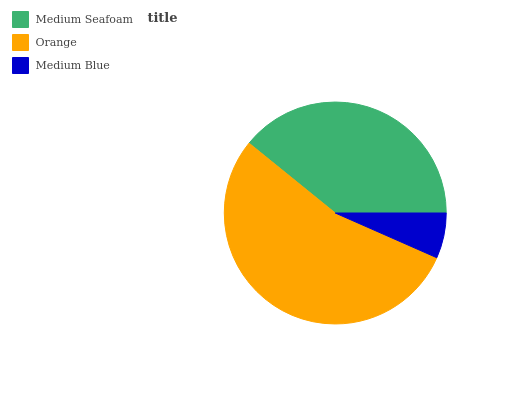Is Medium Blue the minimum?
Answer yes or no. Yes. Is Orange the maximum?
Answer yes or no. Yes. Is Orange the minimum?
Answer yes or no. No. Is Medium Blue the maximum?
Answer yes or no. No. Is Orange greater than Medium Blue?
Answer yes or no. Yes. Is Medium Blue less than Orange?
Answer yes or no. Yes. Is Medium Blue greater than Orange?
Answer yes or no. No. Is Orange less than Medium Blue?
Answer yes or no. No. Is Medium Seafoam the high median?
Answer yes or no. Yes. Is Medium Seafoam the low median?
Answer yes or no. Yes. Is Orange the high median?
Answer yes or no. No. Is Medium Blue the low median?
Answer yes or no. No. 